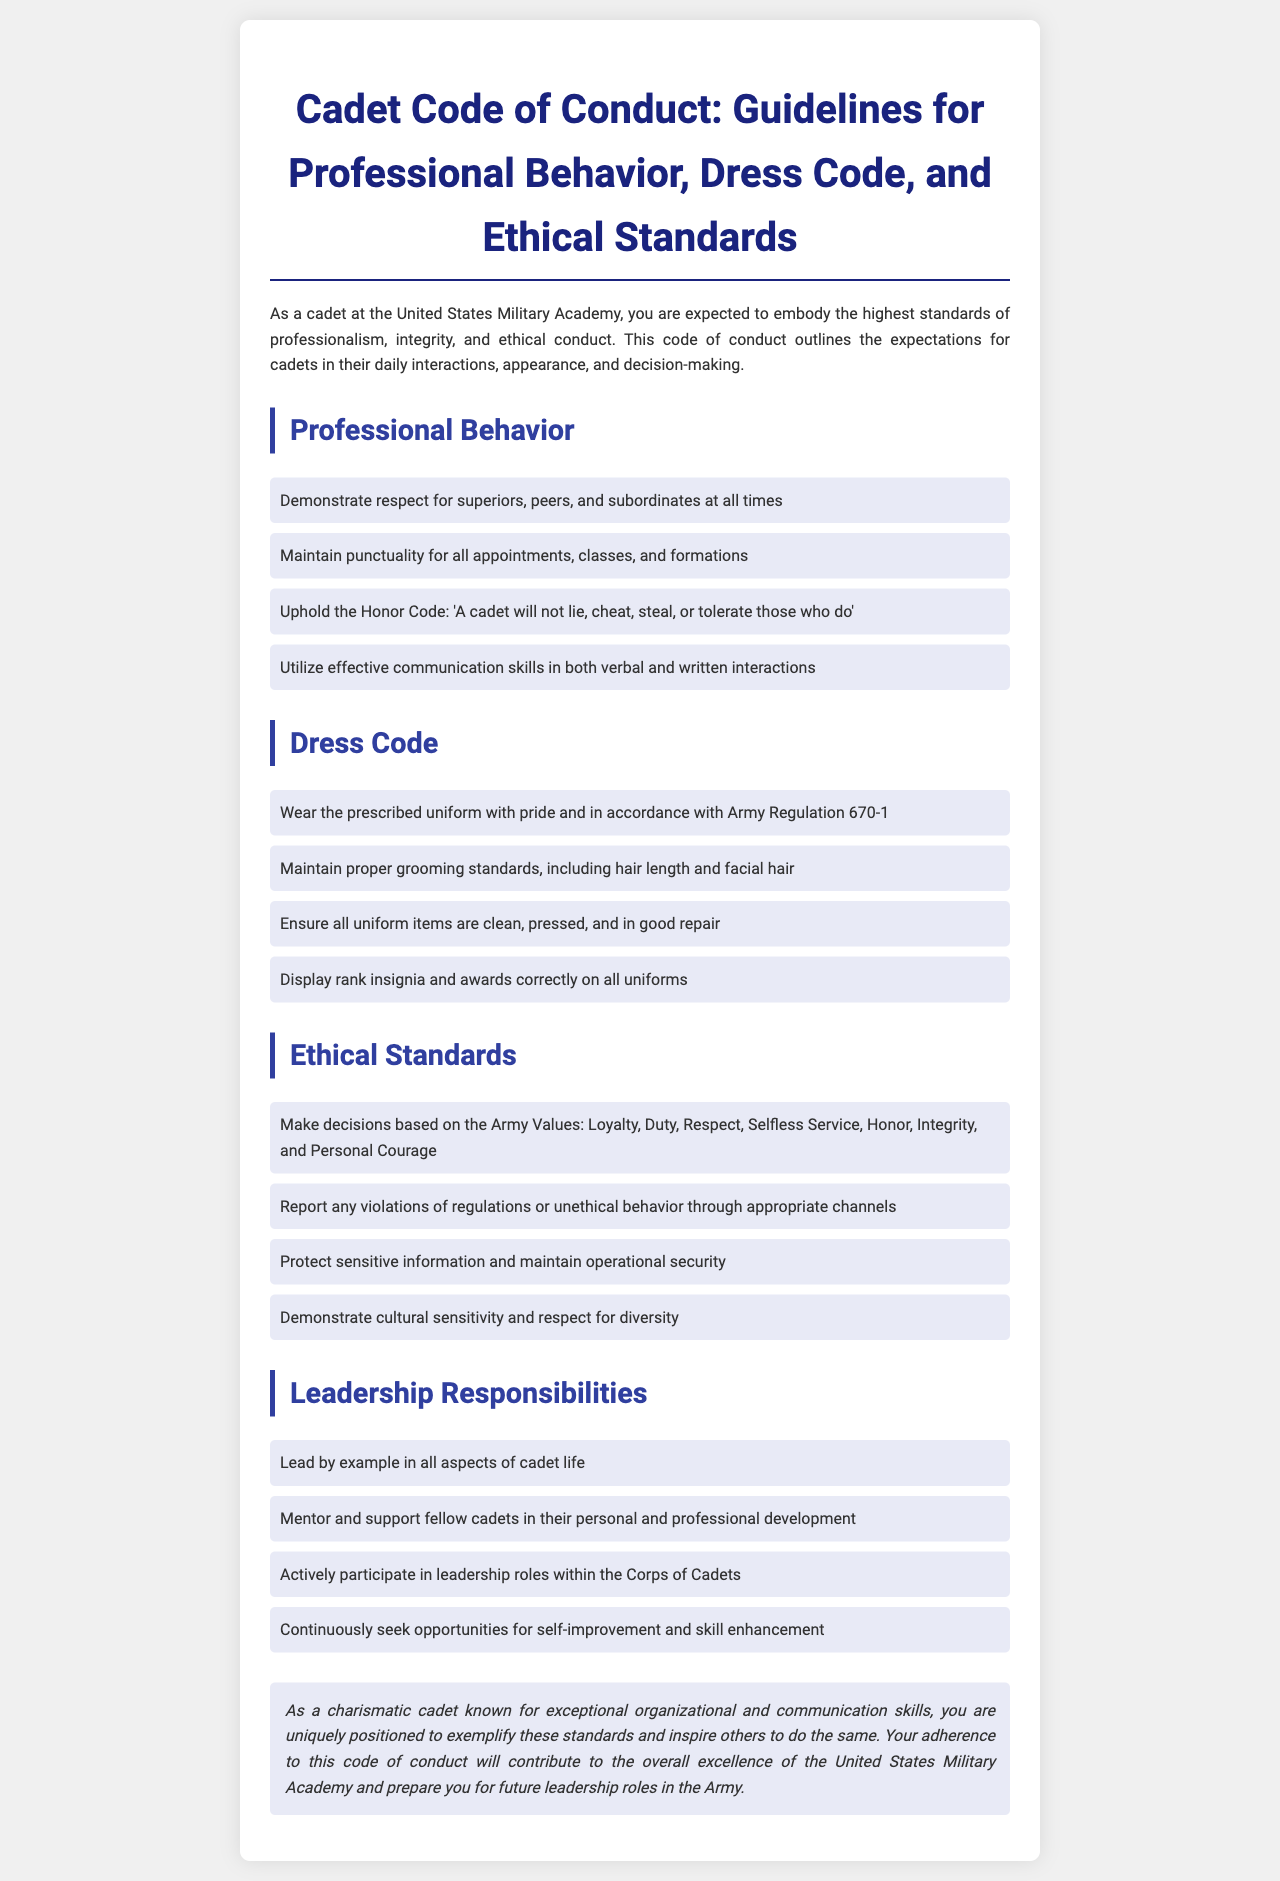what are the expected standards of professional behavior for cadets? The standards for professional behavior include respect, punctuality, upholding the Honor Code, and effective communication skills.
Answer: respect, punctuality, Honor Code, communication skills what is the prescribed uniform standard? The uniform must be worn in accordance with Army Regulation 670-1.
Answer: Army Regulation 670-1 how many ethical standards are outlined in the document? The document outlines four ethical standards important for cadets.
Answer: four what is the first Army Value mentioned? The first Army Value listed is Loyalty.
Answer: Loyalty what is expected from cadets in leadership responsibilities? Cadets are expected to lead by example, mentor others, participate in leadership roles, and seek self-improvement.
Answer: lead by example, mentor, participate, seek self-improvement what is the final remark about cadets in the conclusion? The final remark emphasizes that charismatic cadets can exemplify standards and inspire others.
Answer: exemplify standards and inspire others what are cadets required to do regarding grooming standards? Cadets must maintain proper grooming standards, including hair length and facial hair.
Answer: proper grooming standards what is the stance on reporting violations? The document states that violations or unethical behavior must be reported through appropriate channels.
Answer: report through appropriate channels 